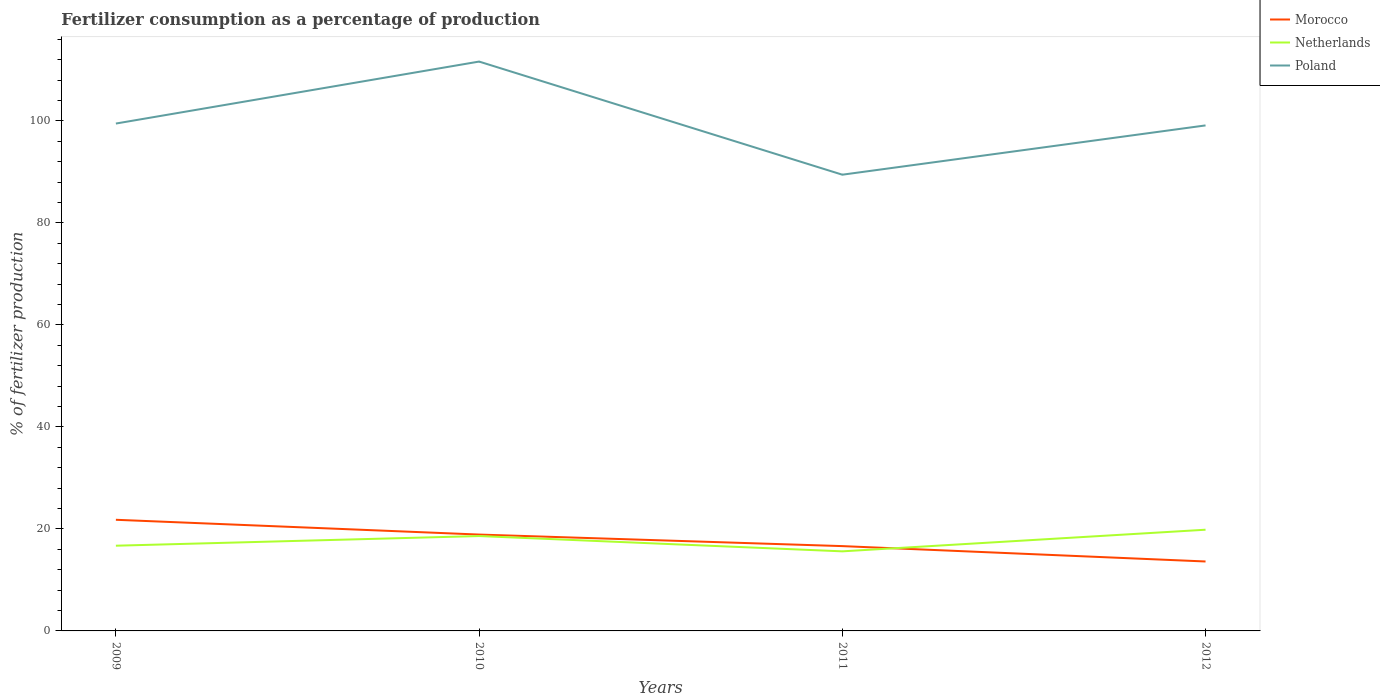How many different coloured lines are there?
Offer a terse response. 3. Is the number of lines equal to the number of legend labels?
Ensure brevity in your answer.  Yes. Across all years, what is the maximum percentage of fertilizers consumed in Poland?
Your response must be concise. 89.46. What is the total percentage of fertilizers consumed in Morocco in the graph?
Ensure brevity in your answer.  2.26. What is the difference between the highest and the second highest percentage of fertilizers consumed in Morocco?
Provide a short and direct response. 8.18. Is the percentage of fertilizers consumed in Netherlands strictly greater than the percentage of fertilizers consumed in Poland over the years?
Make the answer very short. Yes. How many years are there in the graph?
Provide a succinct answer. 4. Are the values on the major ticks of Y-axis written in scientific E-notation?
Your answer should be compact. No. Where does the legend appear in the graph?
Provide a short and direct response. Top right. How are the legend labels stacked?
Make the answer very short. Vertical. What is the title of the graph?
Offer a very short reply. Fertilizer consumption as a percentage of production. What is the label or title of the Y-axis?
Offer a very short reply. % of fertilizer production. What is the % of fertilizer production in Morocco in 2009?
Offer a terse response. 21.79. What is the % of fertilizer production in Netherlands in 2009?
Provide a succinct answer. 16.71. What is the % of fertilizer production of Poland in 2009?
Your answer should be compact. 99.49. What is the % of fertilizer production in Morocco in 2010?
Give a very brief answer. 18.9. What is the % of fertilizer production in Netherlands in 2010?
Offer a very short reply. 18.6. What is the % of fertilizer production in Poland in 2010?
Offer a very short reply. 111.64. What is the % of fertilizer production in Morocco in 2011?
Keep it short and to the point. 16.63. What is the % of fertilizer production in Netherlands in 2011?
Offer a very short reply. 15.6. What is the % of fertilizer production in Poland in 2011?
Your answer should be very brief. 89.46. What is the % of fertilizer production of Morocco in 2012?
Ensure brevity in your answer.  13.62. What is the % of fertilizer production of Netherlands in 2012?
Ensure brevity in your answer.  19.84. What is the % of fertilizer production in Poland in 2012?
Ensure brevity in your answer.  99.12. Across all years, what is the maximum % of fertilizer production of Morocco?
Keep it short and to the point. 21.79. Across all years, what is the maximum % of fertilizer production of Netherlands?
Give a very brief answer. 19.84. Across all years, what is the maximum % of fertilizer production in Poland?
Provide a short and direct response. 111.64. Across all years, what is the minimum % of fertilizer production of Morocco?
Your response must be concise. 13.62. Across all years, what is the minimum % of fertilizer production in Netherlands?
Make the answer very short. 15.6. Across all years, what is the minimum % of fertilizer production in Poland?
Your response must be concise. 89.46. What is the total % of fertilizer production of Morocco in the graph?
Offer a very short reply. 70.93. What is the total % of fertilizer production in Netherlands in the graph?
Offer a very short reply. 70.76. What is the total % of fertilizer production of Poland in the graph?
Your response must be concise. 399.71. What is the difference between the % of fertilizer production of Morocco in 2009 and that in 2010?
Give a very brief answer. 2.9. What is the difference between the % of fertilizer production of Netherlands in 2009 and that in 2010?
Make the answer very short. -1.89. What is the difference between the % of fertilizer production in Poland in 2009 and that in 2010?
Offer a terse response. -12.15. What is the difference between the % of fertilizer production of Morocco in 2009 and that in 2011?
Offer a terse response. 5.16. What is the difference between the % of fertilizer production of Netherlands in 2009 and that in 2011?
Provide a succinct answer. 1.1. What is the difference between the % of fertilizer production of Poland in 2009 and that in 2011?
Keep it short and to the point. 10.03. What is the difference between the % of fertilizer production in Morocco in 2009 and that in 2012?
Ensure brevity in your answer.  8.18. What is the difference between the % of fertilizer production in Netherlands in 2009 and that in 2012?
Your response must be concise. -3.14. What is the difference between the % of fertilizer production in Poland in 2009 and that in 2012?
Your response must be concise. 0.37. What is the difference between the % of fertilizer production of Morocco in 2010 and that in 2011?
Your answer should be compact. 2.26. What is the difference between the % of fertilizer production of Netherlands in 2010 and that in 2011?
Give a very brief answer. 3. What is the difference between the % of fertilizer production in Poland in 2010 and that in 2011?
Give a very brief answer. 22.18. What is the difference between the % of fertilizer production of Morocco in 2010 and that in 2012?
Provide a short and direct response. 5.28. What is the difference between the % of fertilizer production in Netherlands in 2010 and that in 2012?
Ensure brevity in your answer.  -1.24. What is the difference between the % of fertilizer production of Poland in 2010 and that in 2012?
Provide a short and direct response. 12.52. What is the difference between the % of fertilizer production of Morocco in 2011 and that in 2012?
Provide a short and direct response. 3.01. What is the difference between the % of fertilizer production in Netherlands in 2011 and that in 2012?
Offer a terse response. -4.24. What is the difference between the % of fertilizer production of Poland in 2011 and that in 2012?
Provide a succinct answer. -9.66. What is the difference between the % of fertilizer production of Morocco in 2009 and the % of fertilizer production of Netherlands in 2010?
Your answer should be very brief. 3.19. What is the difference between the % of fertilizer production in Morocco in 2009 and the % of fertilizer production in Poland in 2010?
Keep it short and to the point. -89.85. What is the difference between the % of fertilizer production in Netherlands in 2009 and the % of fertilizer production in Poland in 2010?
Provide a short and direct response. -94.93. What is the difference between the % of fertilizer production of Morocco in 2009 and the % of fertilizer production of Netherlands in 2011?
Offer a terse response. 6.19. What is the difference between the % of fertilizer production in Morocco in 2009 and the % of fertilizer production in Poland in 2011?
Your answer should be very brief. -67.67. What is the difference between the % of fertilizer production of Netherlands in 2009 and the % of fertilizer production of Poland in 2011?
Give a very brief answer. -72.75. What is the difference between the % of fertilizer production in Morocco in 2009 and the % of fertilizer production in Netherlands in 2012?
Ensure brevity in your answer.  1.95. What is the difference between the % of fertilizer production of Morocco in 2009 and the % of fertilizer production of Poland in 2012?
Offer a terse response. -77.33. What is the difference between the % of fertilizer production of Netherlands in 2009 and the % of fertilizer production of Poland in 2012?
Give a very brief answer. -82.41. What is the difference between the % of fertilizer production in Morocco in 2010 and the % of fertilizer production in Netherlands in 2011?
Make the answer very short. 3.29. What is the difference between the % of fertilizer production in Morocco in 2010 and the % of fertilizer production in Poland in 2011?
Your response must be concise. -70.56. What is the difference between the % of fertilizer production in Netherlands in 2010 and the % of fertilizer production in Poland in 2011?
Offer a very short reply. -70.86. What is the difference between the % of fertilizer production of Morocco in 2010 and the % of fertilizer production of Netherlands in 2012?
Offer a terse response. -0.95. What is the difference between the % of fertilizer production in Morocco in 2010 and the % of fertilizer production in Poland in 2012?
Your answer should be compact. -80.23. What is the difference between the % of fertilizer production of Netherlands in 2010 and the % of fertilizer production of Poland in 2012?
Make the answer very short. -80.52. What is the difference between the % of fertilizer production in Morocco in 2011 and the % of fertilizer production in Netherlands in 2012?
Provide a short and direct response. -3.21. What is the difference between the % of fertilizer production in Morocco in 2011 and the % of fertilizer production in Poland in 2012?
Keep it short and to the point. -82.49. What is the difference between the % of fertilizer production of Netherlands in 2011 and the % of fertilizer production of Poland in 2012?
Your response must be concise. -83.52. What is the average % of fertilizer production of Morocco per year?
Offer a very short reply. 17.73. What is the average % of fertilizer production in Netherlands per year?
Give a very brief answer. 17.69. What is the average % of fertilizer production in Poland per year?
Your response must be concise. 99.93. In the year 2009, what is the difference between the % of fertilizer production in Morocco and % of fertilizer production in Netherlands?
Your response must be concise. 5.08. In the year 2009, what is the difference between the % of fertilizer production of Morocco and % of fertilizer production of Poland?
Give a very brief answer. -77.7. In the year 2009, what is the difference between the % of fertilizer production of Netherlands and % of fertilizer production of Poland?
Make the answer very short. -82.78. In the year 2010, what is the difference between the % of fertilizer production of Morocco and % of fertilizer production of Netherlands?
Make the answer very short. 0.29. In the year 2010, what is the difference between the % of fertilizer production in Morocco and % of fertilizer production in Poland?
Provide a short and direct response. -92.75. In the year 2010, what is the difference between the % of fertilizer production of Netherlands and % of fertilizer production of Poland?
Offer a very short reply. -93.04. In the year 2011, what is the difference between the % of fertilizer production in Morocco and % of fertilizer production in Netherlands?
Make the answer very short. 1.03. In the year 2011, what is the difference between the % of fertilizer production of Morocco and % of fertilizer production of Poland?
Your answer should be very brief. -72.83. In the year 2011, what is the difference between the % of fertilizer production in Netherlands and % of fertilizer production in Poland?
Your answer should be compact. -73.86. In the year 2012, what is the difference between the % of fertilizer production in Morocco and % of fertilizer production in Netherlands?
Provide a short and direct response. -6.23. In the year 2012, what is the difference between the % of fertilizer production in Morocco and % of fertilizer production in Poland?
Provide a succinct answer. -85.51. In the year 2012, what is the difference between the % of fertilizer production in Netherlands and % of fertilizer production in Poland?
Offer a terse response. -79.28. What is the ratio of the % of fertilizer production in Morocco in 2009 to that in 2010?
Your answer should be very brief. 1.15. What is the ratio of the % of fertilizer production in Netherlands in 2009 to that in 2010?
Offer a terse response. 0.9. What is the ratio of the % of fertilizer production in Poland in 2009 to that in 2010?
Offer a terse response. 0.89. What is the ratio of the % of fertilizer production of Morocco in 2009 to that in 2011?
Ensure brevity in your answer.  1.31. What is the ratio of the % of fertilizer production in Netherlands in 2009 to that in 2011?
Your answer should be compact. 1.07. What is the ratio of the % of fertilizer production in Poland in 2009 to that in 2011?
Keep it short and to the point. 1.11. What is the ratio of the % of fertilizer production of Morocco in 2009 to that in 2012?
Your answer should be compact. 1.6. What is the ratio of the % of fertilizer production in Netherlands in 2009 to that in 2012?
Ensure brevity in your answer.  0.84. What is the ratio of the % of fertilizer production of Morocco in 2010 to that in 2011?
Provide a short and direct response. 1.14. What is the ratio of the % of fertilizer production in Netherlands in 2010 to that in 2011?
Provide a short and direct response. 1.19. What is the ratio of the % of fertilizer production of Poland in 2010 to that in 2011?
Make the answer very short. 1.25. What is the ratio of the % of fertilizer production of Morocco in 2010 to that in 2012?
Offer a terse response. 1.39. What is the ratio of the % of fertilizer production in Netherlands in 2010 to that in 2012?
Keep it short and to the point. 0.94. What is the ratio of the % of fertilizer production of Poland in 2010 to that in 2012?
Give a very brief answer. 1.13. What is the ratio of the % of fertilizer production in Morocco in 2011 to that in 2012?
Offer a terse response. 1.22. What is the ratio of the % of fertilizer production in Netherlands in 2011 to that in 2012?
Give a very brief answer. 0.79. What is the ratio of the % of fertilizer production of Poland in 2011 to that in 2012?
Give a very brief answer. 0.9. What is the difference between the highest and the second highest % of fertilizer production in Morocco?
Give a very brief answer. 2.9. What is the difference between the highest and the second highest % of fertilizer production in Netherlands?
Provide a succinct answer. 1.24. What is the difference between the highest and the second highest % of fertilizer production in Poland?
Your answer should be compact. 12.15. What is the difference between the highest and the lowest % of fertilizer production of Morocco?
Provide a short and direct response. 8.18. What is the difference between the highest and the lowest % of fertilizer production of Netherlands?
Make the answer very short. 4.24. What is the difference between the highest and the lowest % of fertilizer production of Poland?
Ensure brevity in your answer.  22.18. 